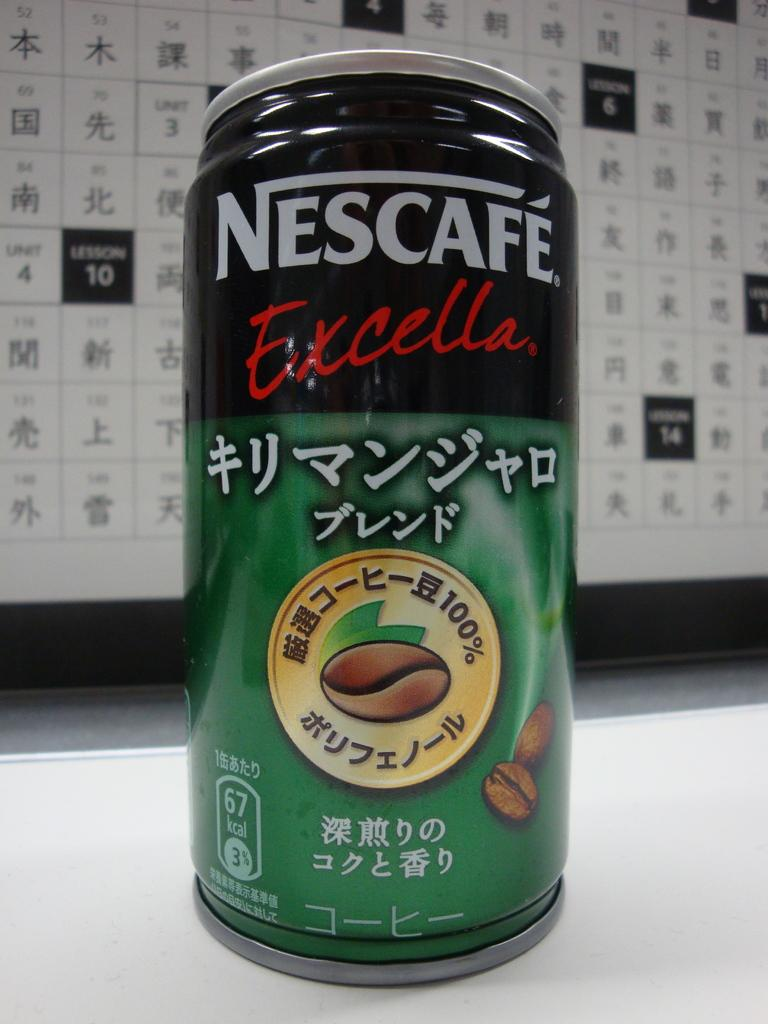<image>
Write a terse but informative summary of the picture. A can of Nescafe Excella with a coffee bean on it. 